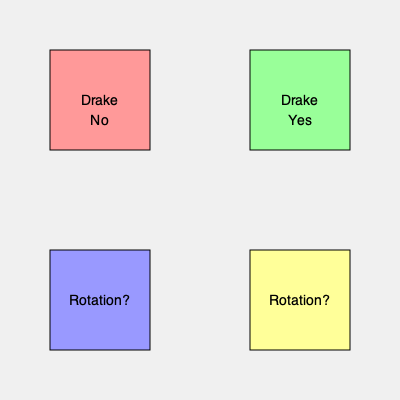Which rotation of the Drake meme template shown above would be correct according to its standard format? To determine the correct rotation of the Drake meme template, we need to follow these steps:

1. Recognize the meme: This is the popular "Drake Hotline Bling" meme template.

2. Understand the standard format:
   a. The template typically consists of two panels on the left and two on the right.
   b. Drake is shown in both left panels, expressing different reactions.
   c. The top-left panel shows Drake rejecting something (Drake No).
   d. The bottom-left panel shows Drake approving something (Drake Yes).
   e. The right panels contain the text or images being compared.

3. Analyze the given image:
   a. The top-left panel correctly shows "Drake No".
   b. The top-right panel incorrectly shows "Drake Yes".
   c. The bottom panels are placeholder "Rotation?" squares.

4. Determine the correct rotation:
   To fix this, we need to rotate the image 90 degrees clockwise. This will:
   a. Move "Drake No" to the left side.
   b. Move "Drake Yes" to the bottom-left.
   c. Place the placeholder panels on the right side.

Thus, a 90-degree clockwise rotation would correct the meme's format.
Answer: 90 degrees clockwise 